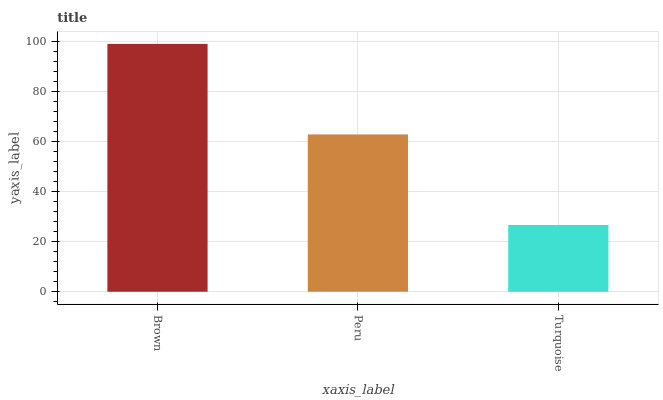Is Turquoise the minimum?
Answer yes or no. Yes. Is Brown the maximum?
Answer yes or no. Yes. Is Peru the minimum?
Answer yes or no. No. Is Peru the maximum?
Answer yes or no. No. Is Brown greater than Peru?
Answer yes or no. Yes. Is Peru less than Brown?
Answer yes or no. Yes. Is Peru greater than Brown?
Answer yes or no. No. Is Brown less than Peru?
Answer yes or no. No. Is Peru the high median?
Answer yes or no. Yes. Is Peru the low median?
Answer yes or no. Yes. Is Turquoise the high median?
Answer yes or no. No. Is Turquoise the low median?
Answer yes or no. No. 